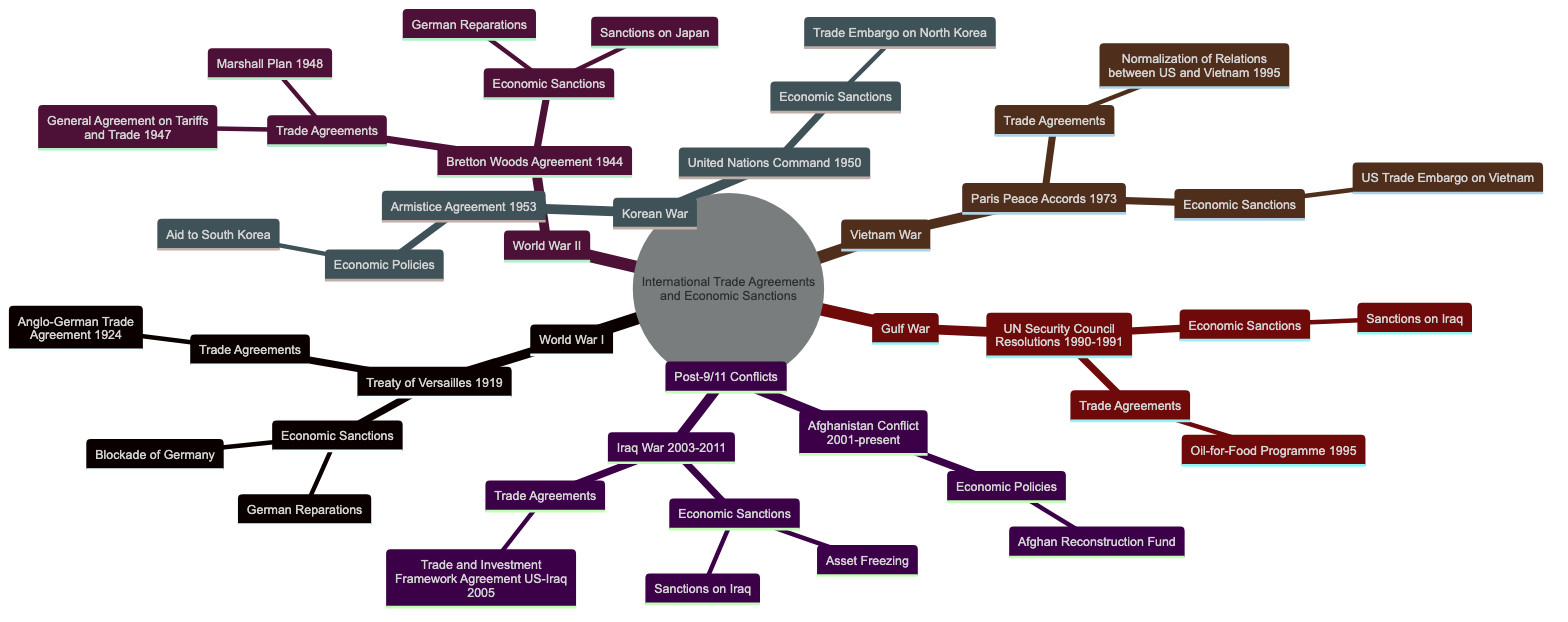What international trade agreement emerged from the Treaty of Versailles? The Treaty of Versailles is linked to the Anglo-German Trade Agreement from 1924. This can be found as a child node under the Treaty of Versailles, indicating that this was the trade agreement formed following World War I.
Answer: Anglo-German Trade Agreement 1924 How many economic sanctions were imposed as a result of World War II? Upon examining the World War II section, you will find two economic sanctions listed under the Bretton Woods Agreement: German Reparations and Sanctions on Japan. Therefore, the total number is two.
Answer: 2 Which conflict led to the United Nations Command in 1950? The United Nations Command (1950) is specifically listed under the Korean War section of the diagram. Therefore, the conflict associated with it is the Korean War.
Answer: Korean War What economic policies were associated with the Armistice Agreement of 1953? Looking closely at the Armistice Agreement (1953) under the Korean War, the only economic policy that is mentioned is Aid to South Korea. Thus, this is the policy that corresponds to that agreement.
Answer: Aid to South Korea How many trade agreements are linked to the Gulf War? In the Gulf War section, there are two entries listed: the UN Security Council Resolutions along with their associated sanctions and trade agreements. However, only one specific trade agreement, the Oil-for-Food Programme, is under this section. Thus, the total number is one.
Answer: 1 What sanction was imposed on Iraq during the post-9/11 conflicts? Under the Iraq War section of the Post-9/11 Conflicts, both Sanctions on Iraq and Asset Freezing are listed. Therefore, at least one of these sanctions was imposed during that period.
Answer: Sanctions on Iraq Which agreement normalized relations between the US and Vietnam? The diagram shows that the Paris Peace Accords in 1973 are connected to the Normalization of Relations between the US and Vietnam in 1995 as one of its trade agreements.
Answer: Normalization of Relations between US and Vietnam 1995 What was the economic sanction against North Korea during the Korean War? From the Korean War section, the economic sanction specifically listed under the United Nations Command (1950) is the Trade Embargo on North Korea. This directly addresses the query.
Answer: Trade Embargo on North Korea What major economic initiative was launched in Iraq in 2005? The Iraq War section indicates a specific trade agreement named the Trade and Investment Framework Agreement between the US and Iraq, which was established in 2005. This is the major economic initiative tied to that timeframe.
Answer: Trade and Investment Framework Agreement 2005 